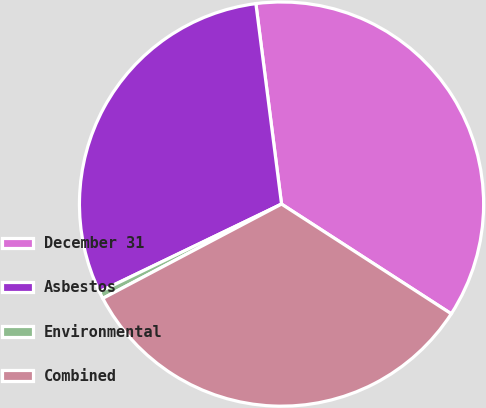Convert chart to OTSL. <chart><loc_0><loc_0><loc_500><loc_500><pie_chart><fcel>December 31<fcel>Asbestos<fcel>Environmental<fcel>Combined<nl><fcel>36.16%<fcel>30.12%<fcel>0.58%<fcel>33.14%<nl></chart> 